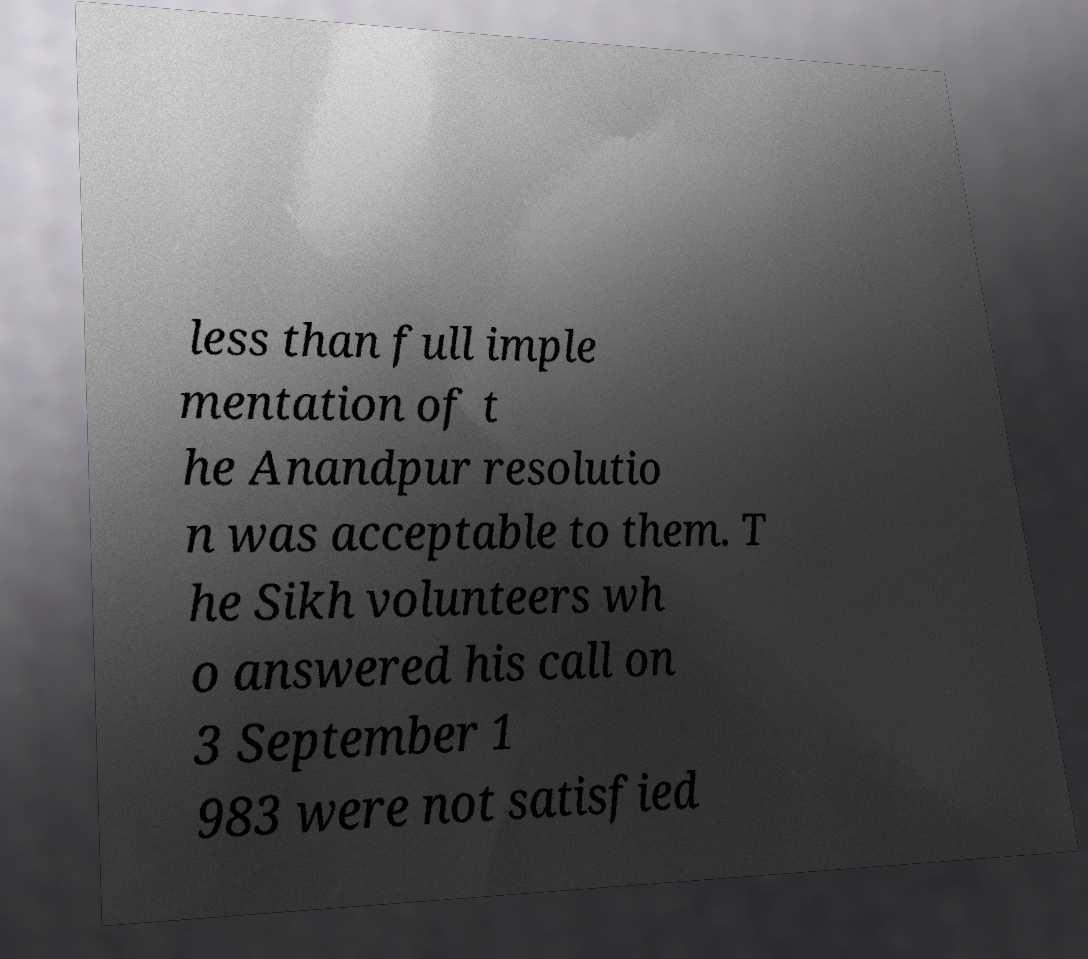For documentation purposes, I need the text within this image transcribed. Could you provide that? less than full imple mentation of t he Anandpur resolutio n was acceptable to them. T he Sikh volunteers wh o answered his call on 3 September 1 983 were not satisfied 